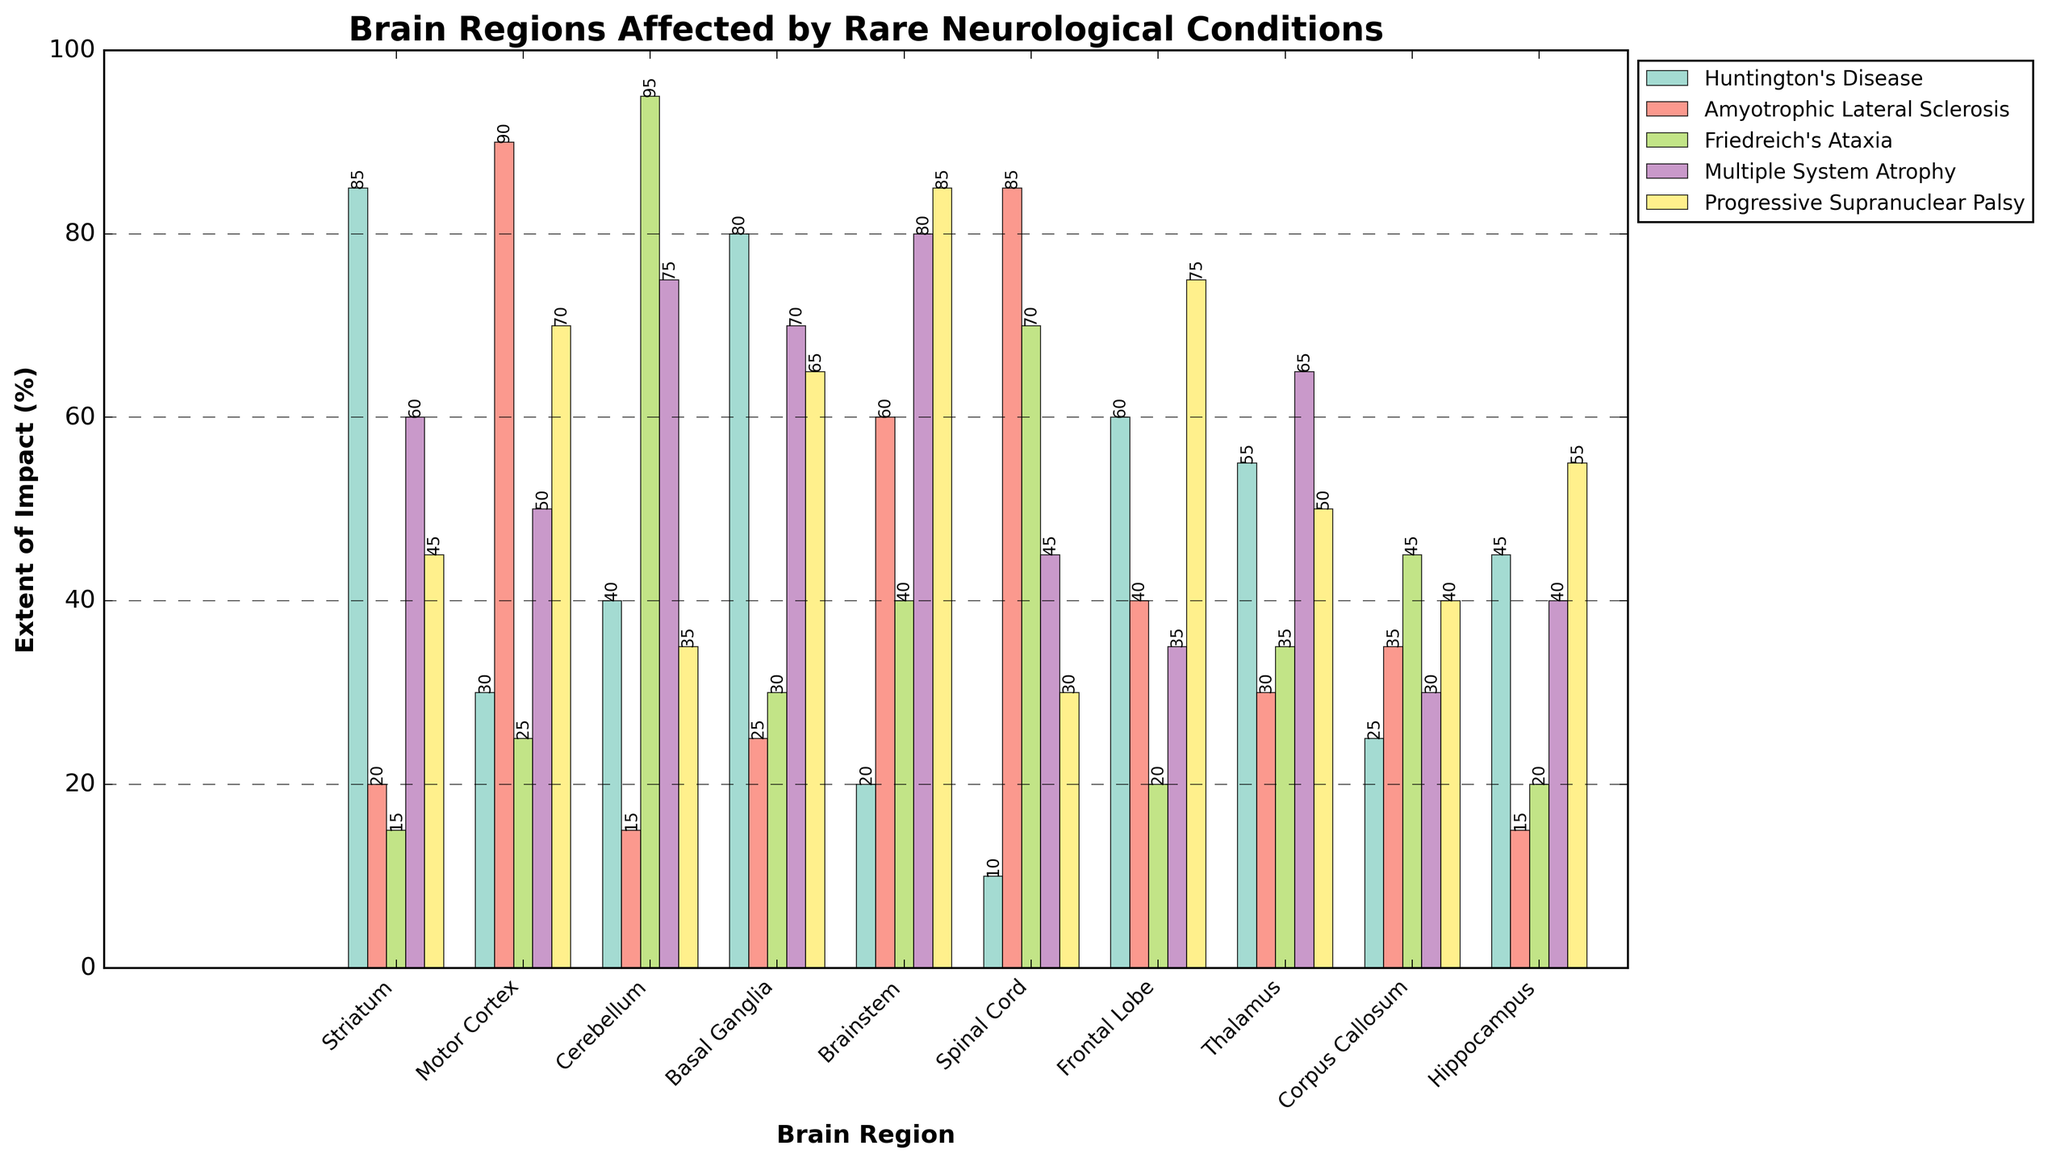What is the Brain Region most affected by Huntington's Disease? The bars for Huntington's Disease are the highest for Striatum compared to other regions.
Answer: Striatum Which two neurological conditions severely impact the Spinal Cord and by how much? Looking at the bars for the Spinal Cord, Amyotrophic Lateral Sclerosis and Friedreich's Ataxia have the highest values, 85 and 70 respectively.
Answer: Amyotrophic Lateral Sclerosis (85), Friedreich's Ataxia (70) Which condition has the least impact on the Hippocampus? The height of the bars for Hippocampus shows that Amyotrophic Lateral Sclerosis has the smallest value at 15.
Answer: Amyotrophic Lateral Sclerosis (15) Between the Motor Cortex and Frontal Lobe, which brain region does Multiple System Atrophy affect more? Compare the height of the bars for Multiple System Atrophy in Motor Cortex (50) and Frontal Lobe (35). The Motor Cortex is higher.
Answer: Motor Cortex (50) What is the average extent of impact on the Thalamus by Amyotrophic Lateral Sclerosis and Progressive Supranuclear Palsy? The values for Thalamus are 30 for Amyotrophic Lateral Sclerosis and 50 for Progressive Supranuclear Palsy. The average is (30 + 50) / 2 = 40.
Answer: 40 What is the difference in impact on the Brainstem between Huntington's Disease and Multiple System Atrophy? The values for Brainstem are 20 for Huntington's Disease and 80 for Multiple System Atrophy. The difference is 80 - 20 = 60.
Answer: 60 Which condition shows consistent moderate impact across all brain regions? By visually inspecting the bars and their heights, Multiple System Atrophy and Progressive Supranuclear Palsy generally show moderately high values across various regions. Focus on Multiple System Atrophy shows consistent moderate-high impacts.
Answer: Multiple System Atrophy What is the extent of impact of Progressive Supranuclear Palsy on the Frontal Lobe compared to the Corpus Callosum? The value for Progressive Supranuclear Palsy on the Frontal Lobe is 75, while on the Corpus Callosum it is 40. So, it impacts the Frontal Lobe more.
Answer: Frontal Lobe (75) Considering both the extents of impact, which condition impacts both the Striatum and Cerebellum the least? The values of Huntington's Disease (85, 40), Amyotrophic Lateral Sclerosis (20, 15), Friedreich's Ataxia (15, 95), Multiple System Atrophy (60, 75), Progressive Supranuclear Palsy (45, 35) need to be compared, and Amyotrophic Lateral Sclerosis has the smallest values.
Answer: Amyotrophic Lateral Sclerosis (Striatum: 20, Cerebellum: 15) 